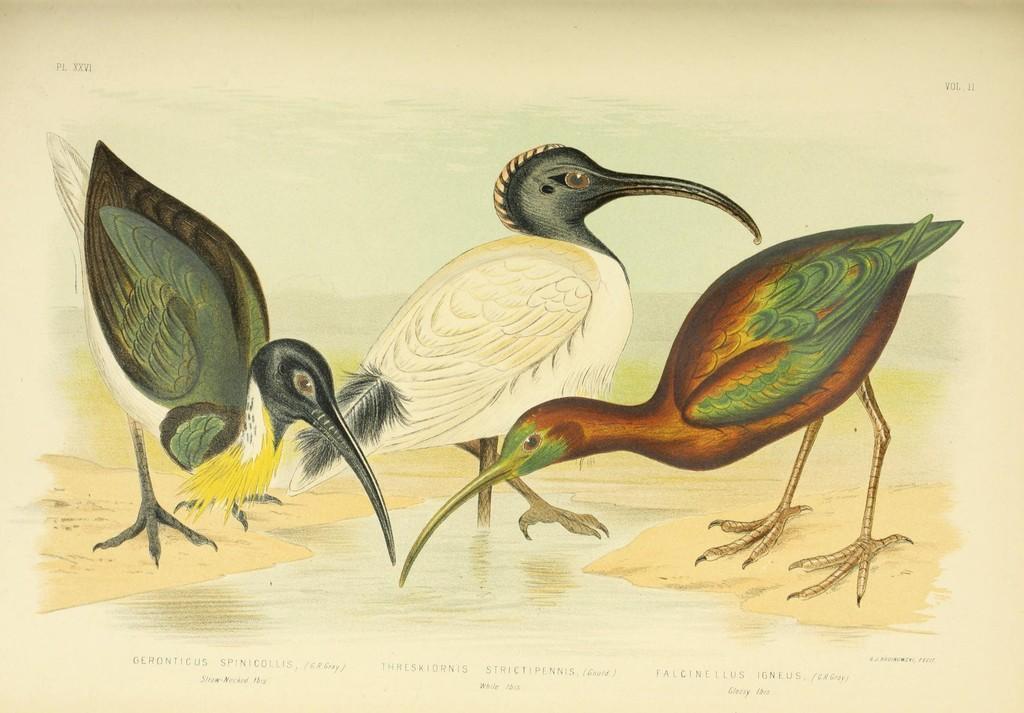How would you summarize this image in a sentence or two? This is a painting,in this painting we can see birds,water. 